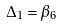Convert formula to latex. <formula><loc_0><loc_0><loc_500><loc_500>\Delta _ { 1 } = \beta _ { 6 }</formula> 